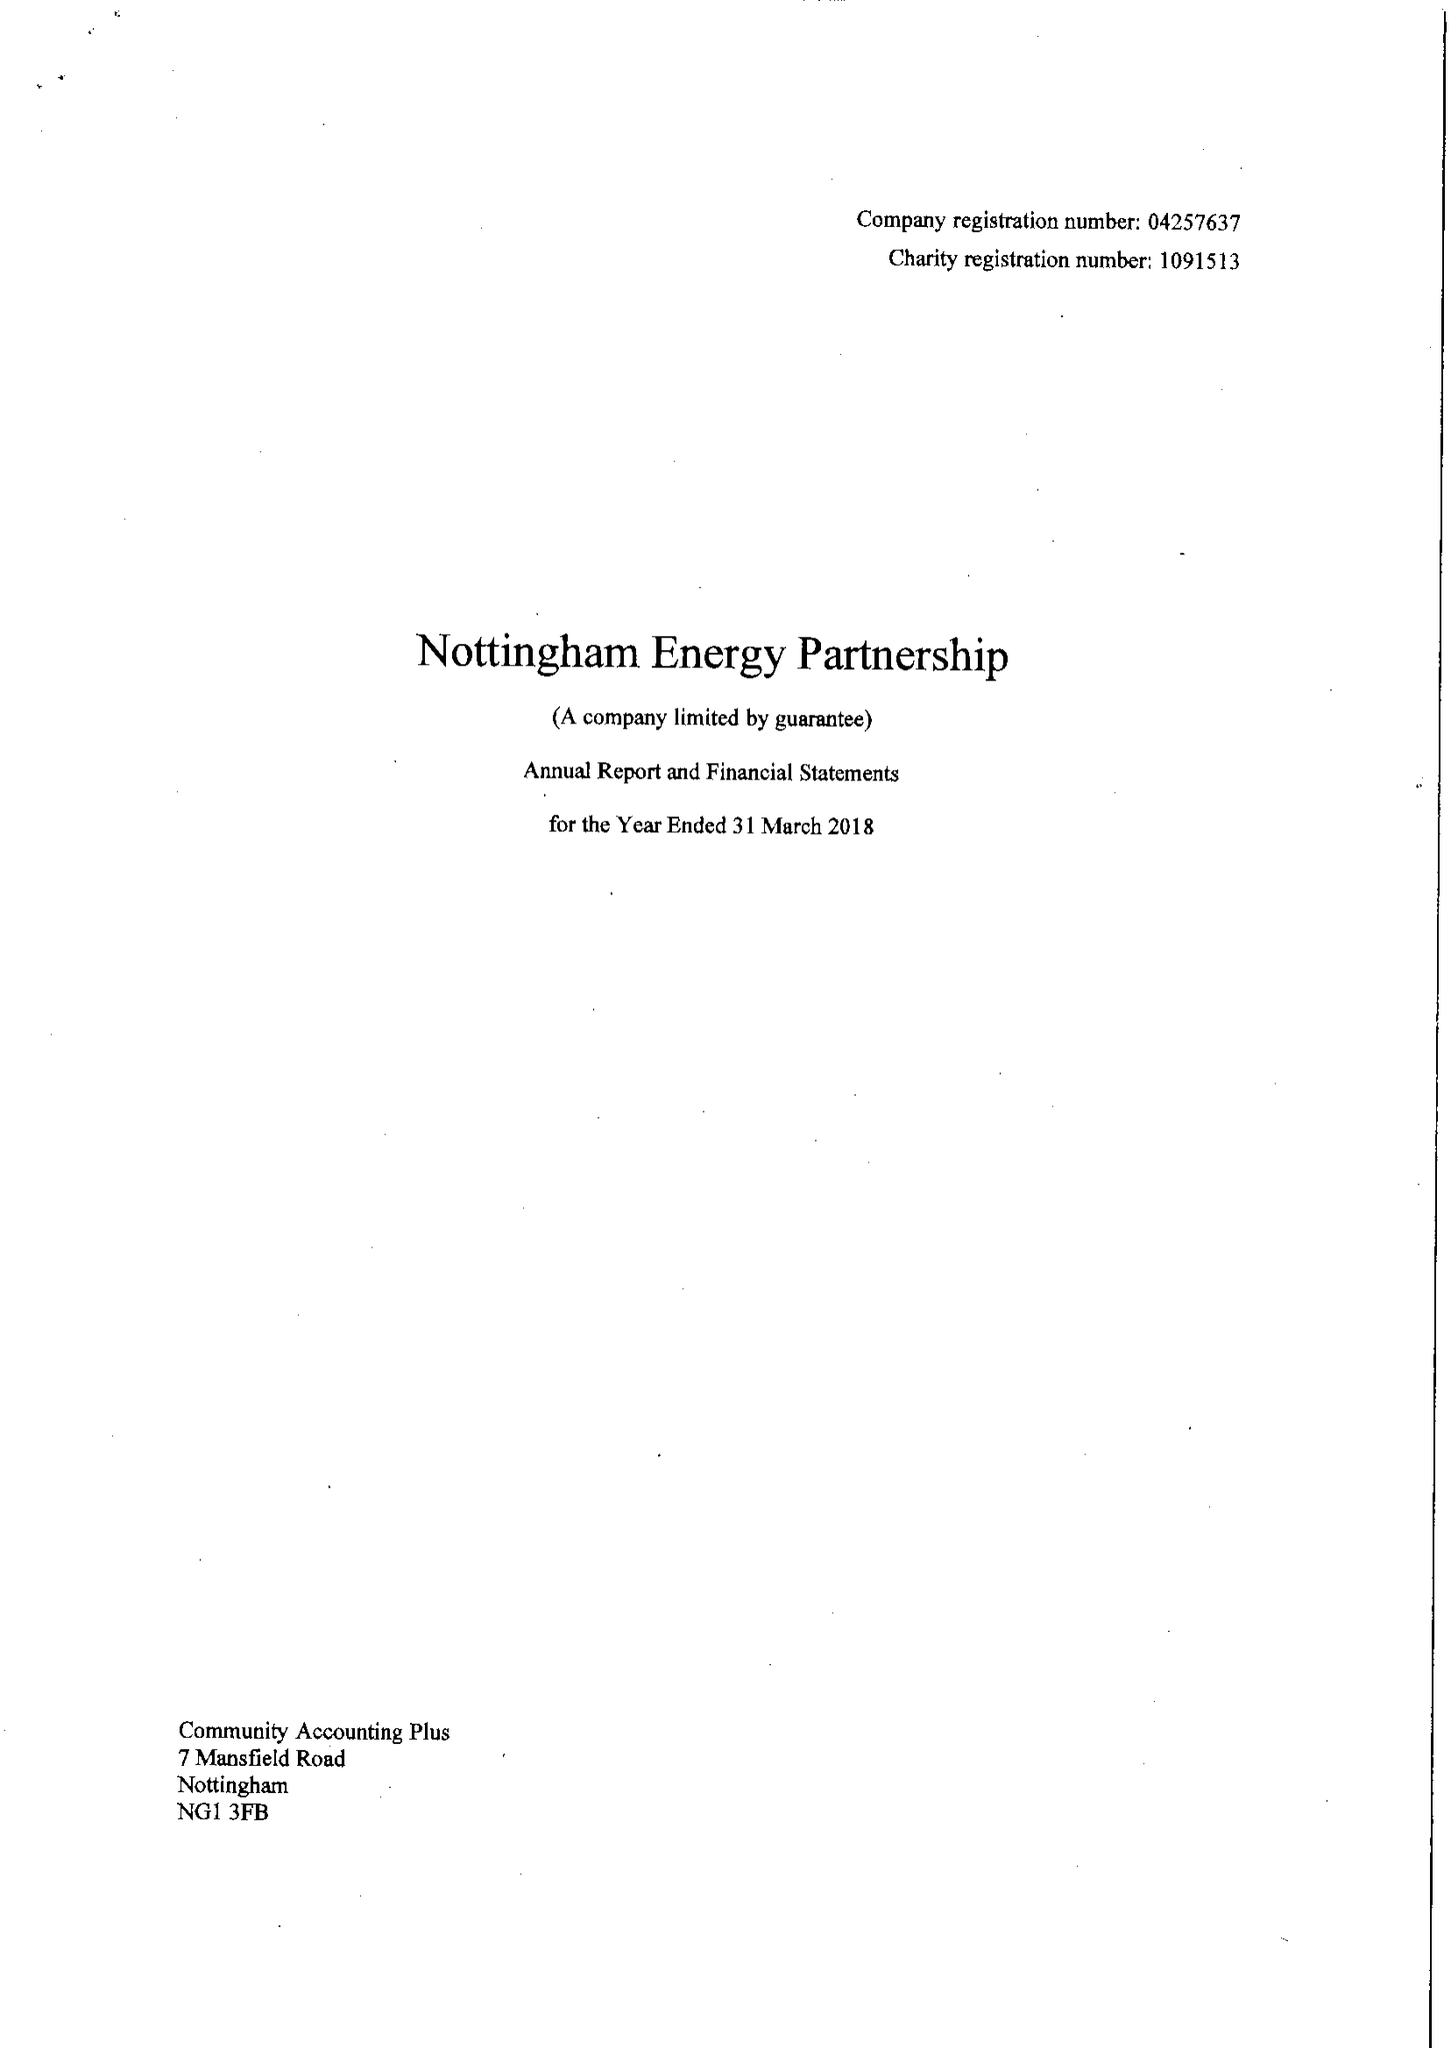What is the value for the address__post_town?
Answer the question using a single word or phrase. NOTTINGHAM 